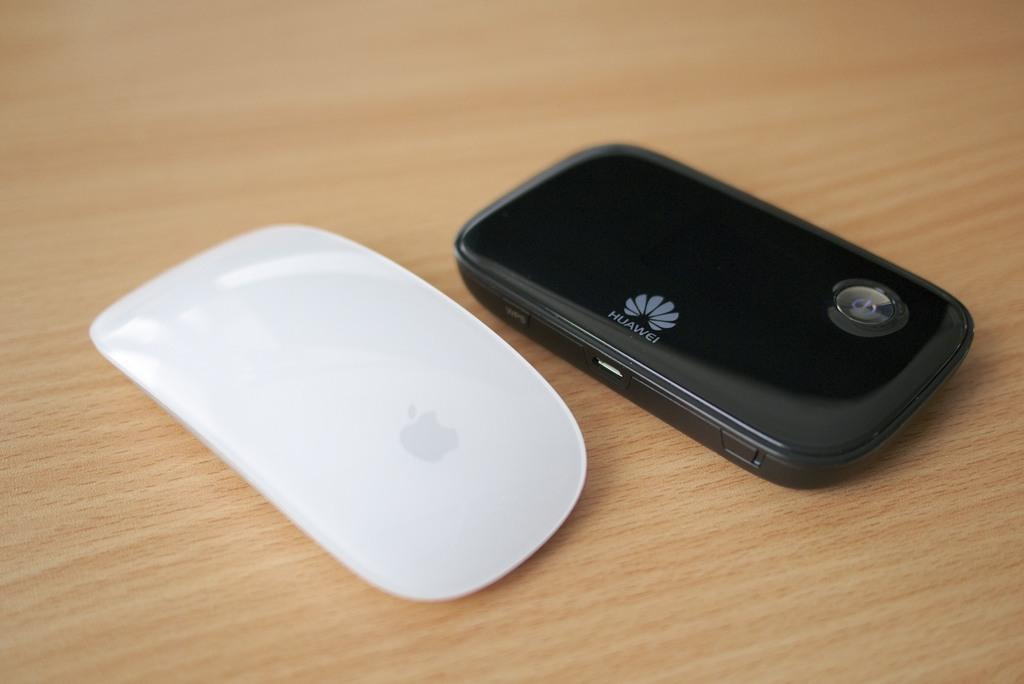Provide a one-sentence caption for the provided image. A Huawei phone sitting on a wood table. 